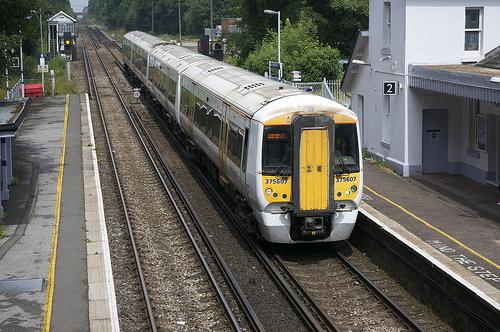Question: who is driving the train?
Choices:
A. Boy.
B. Conductor.
C. Clown.
D. No one.
Answer with the letter. Answer: B 